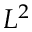<formula> <loc_0><loc_0><loc_500><loc_500>L ^ { 2 }</formula> 